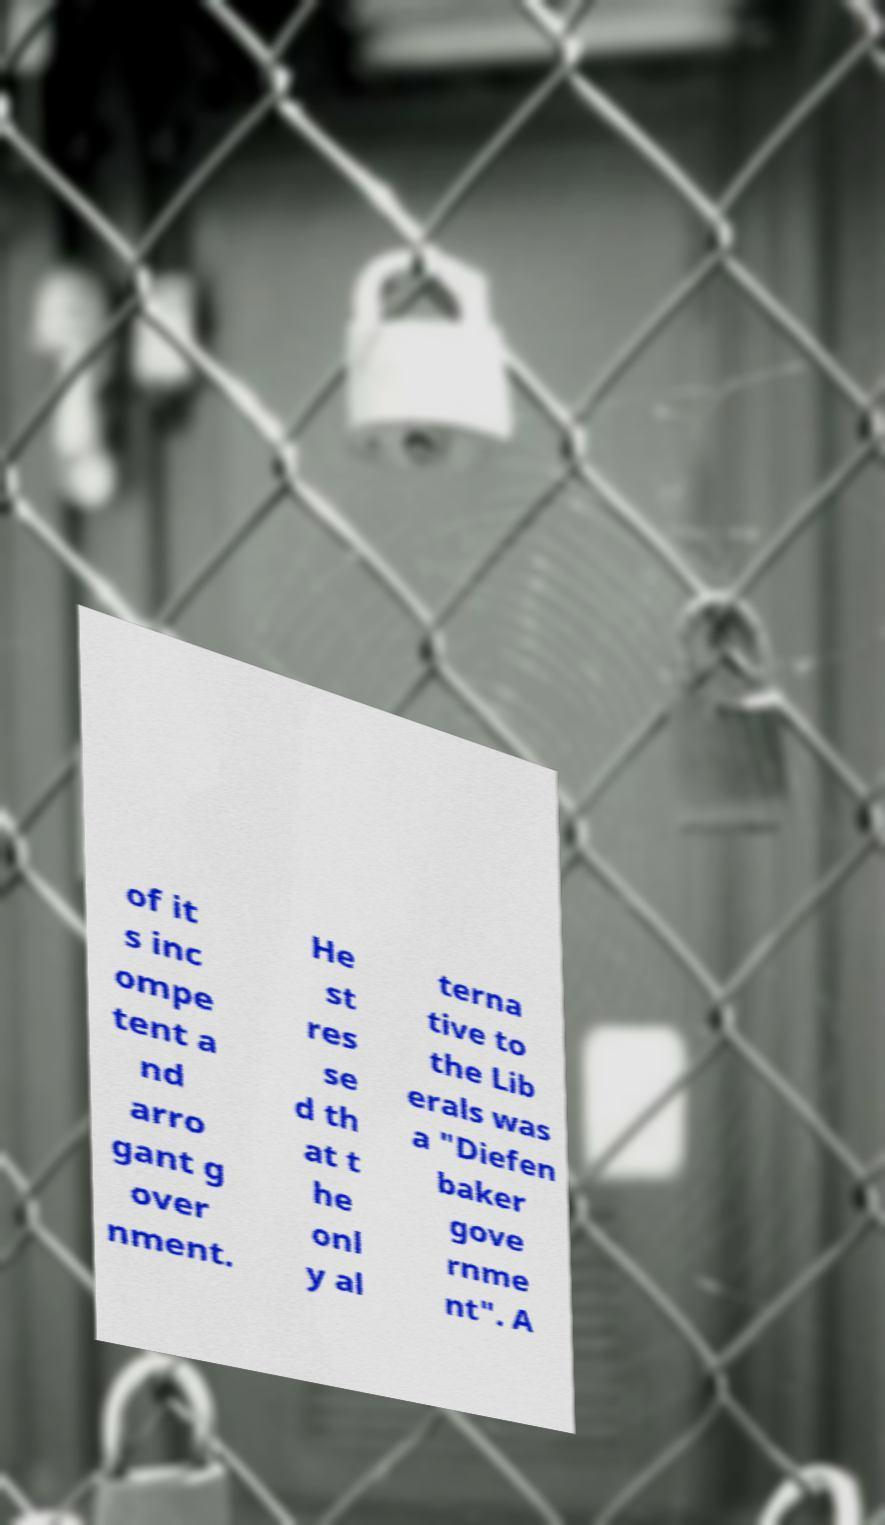For documentation purposes, I need the text within this image transcribed. Could you provide that? of it s inc ompe tent a nd arro gant g over nment. He st res se d th at t he onl y al terna tive to the Lib erals was a "Diefen baker gove rnme nt". A 